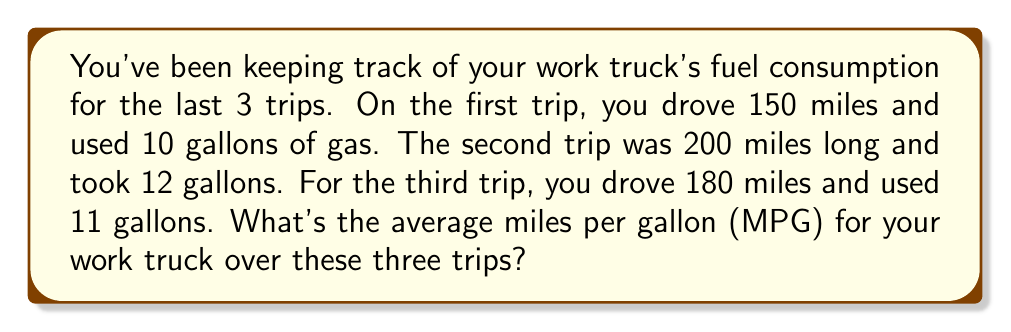Provide a solution to this math problem. To find the average fuel efficiency (MPG) over multiple trips, we need to:

1. Calculate the total distance driven
2. Calculate the total fuel used
3. Divide the total distance by the total fuel used

Let's break it down step-by-step:

1. Total distance:
   $150 + 200 + 180 = 530$ miles

2. Total fuel used:
   $10 + 12 + 11 = 33$ gallons

3. Average MPG calculation:
   $$\text{Average MPG} = \frac{\text{Total Distance}}{\text{Total Fuel Used}}$$
   
   $$\text{Average MPG} = \frac{530 \text{ miles}}{33 \text{ gallons}}$$
   
   $$\text{Average MPG} = 16.06 \text{ miles per gallon}$$

Rounding to the nearest tenth, we get 16.1 MPG.
Answer: 16.1 MPG 